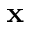<formula> <loc_0><loc_0><loc_500><loc_500>x</formula> 